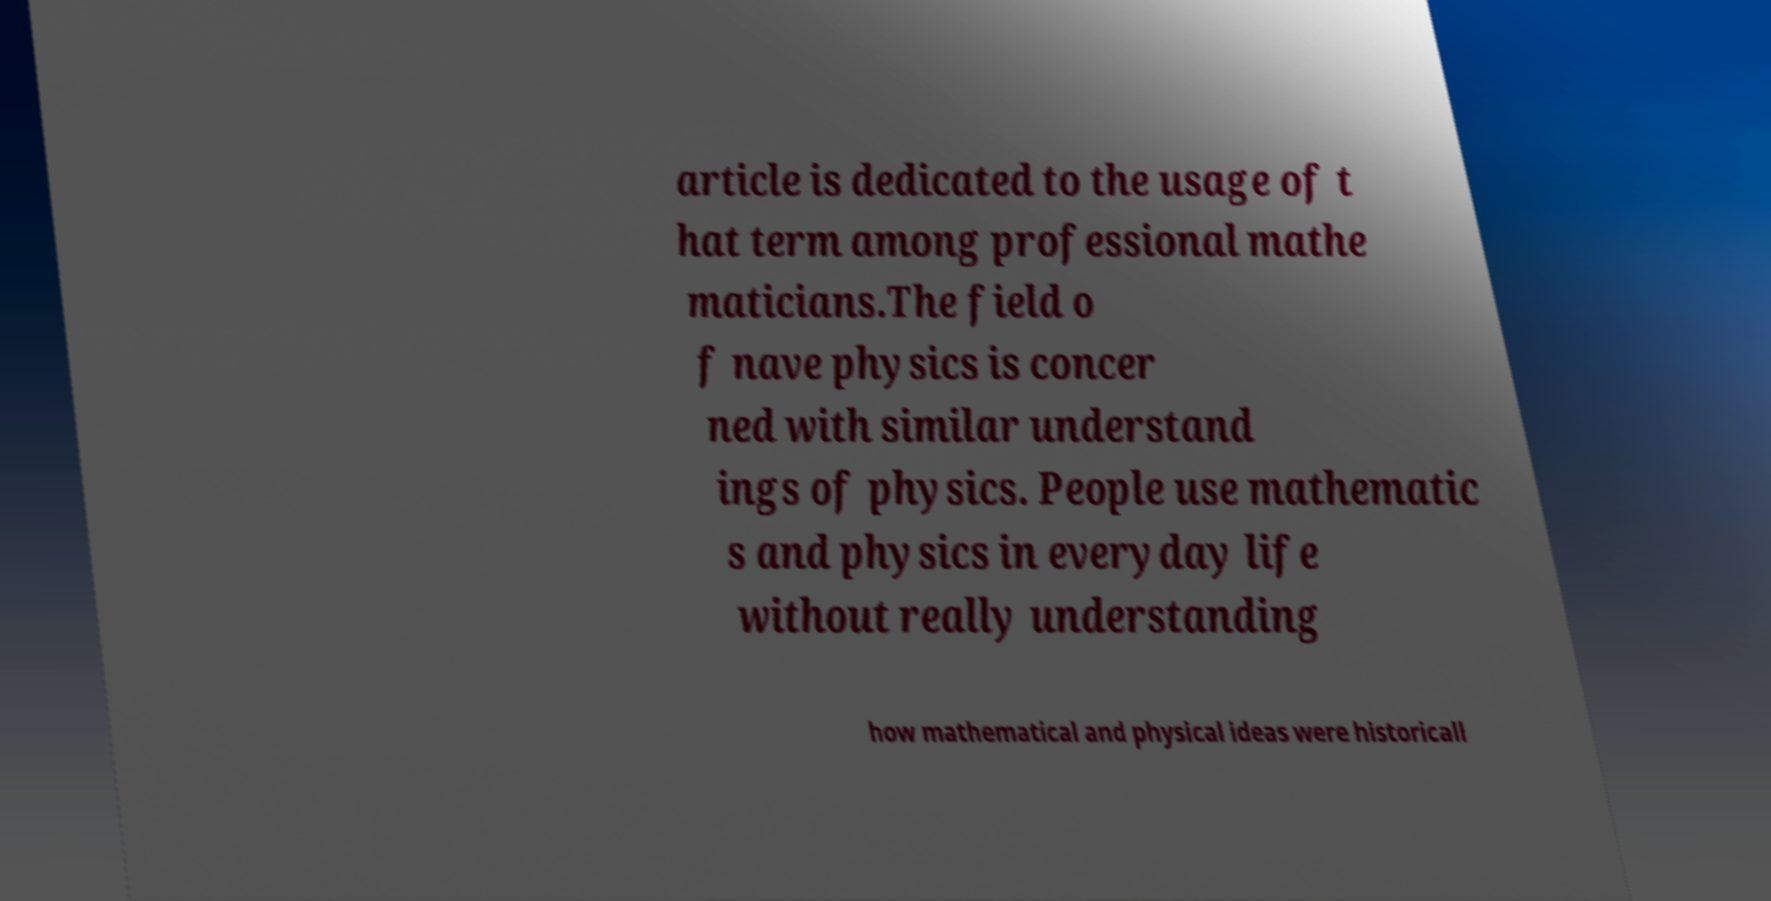Could you assist in decoding the text presented in this image and type it out clearly? article is dedicated to the usage of t hat term among professional mathe maticians.The field o f nave physics is concer ned with similar understand ings of physics. People use mathematic s and physics in everyday life without really understanding how mathematical and physical ideas were historicall 